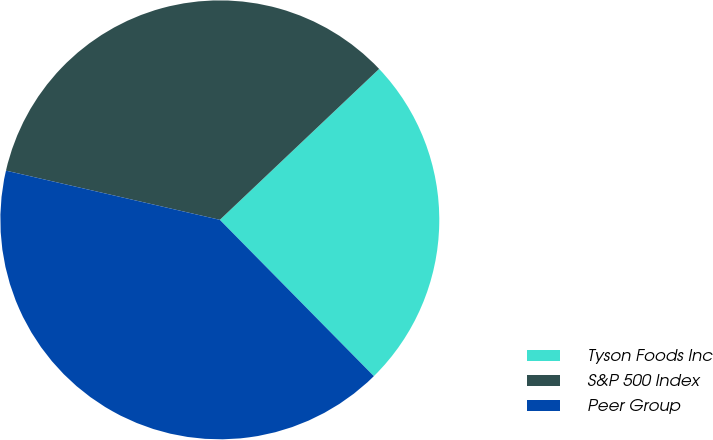Convert chart. <chart><loc_0><loc_0><loc_500><loc_500><pie_chart><fcel>Tyson Foods Inc<fcel>S&P 500 Index<fcel>Peer Group<nl><fcel>24.69%<fcel>34.33%<fcel>40.98%<nl></chart> 